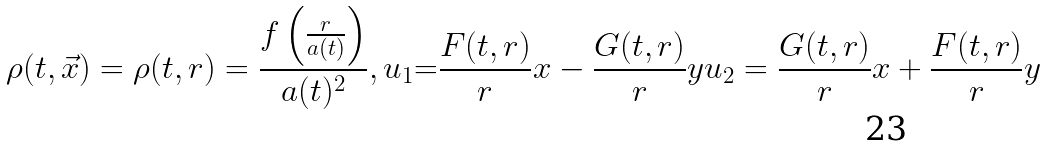Convert formula to latex. <formula><loc_0><loc_0><loc_500><loc_500>\rho ( t , \vec { x } ) = \rho ( t , r ) = \frac { f \left ( \frac { r } { a ( t ) } \right ) } { a ( t ) ^ { 2 } } , { u } _ { 1 } { = } \frac { F ( t , r ) } { r } x - \frac { G ( t , r ) } { r } y u _ { 2 } = \frac { G ( t , r ) } { r } x + \frac { F ( t , r ) } { r } y</formula> 